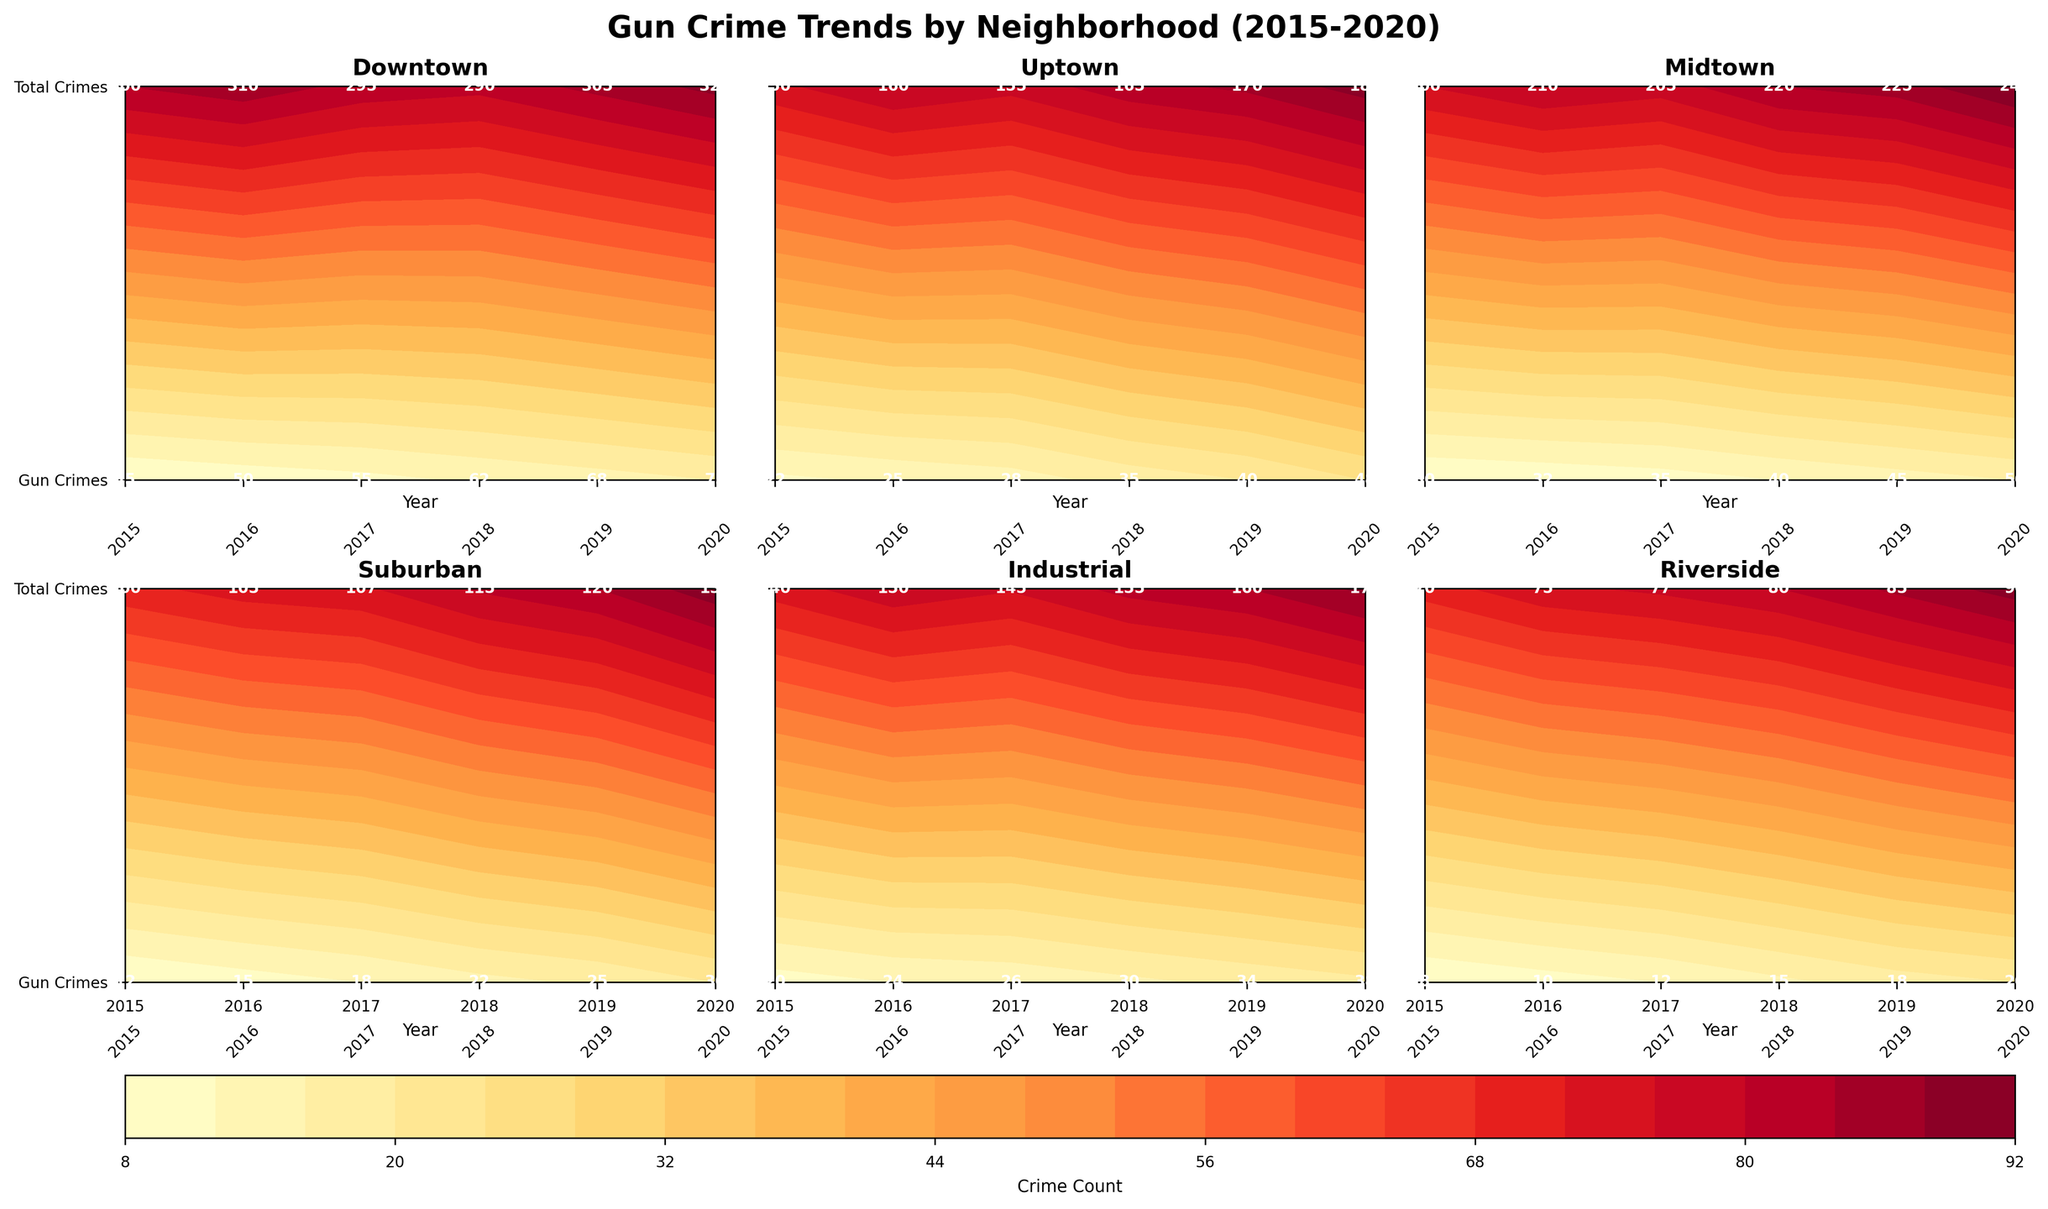What is the title of the figure? The title is typically displayed at the top of the figure; it's used to summarize the content or focus of the figure. For our plot, it reads "Gun Crime Trends by Neighborhood (2015-2020)".
Answer: Gun Crime Trends by Neighborhood (2015-2020) What does the y-axis represent in each subplot? Each subplot has a y-axis with labels that differentiate between "Gun Crimes" (at the bottom) and "Total Crimes" (at the top of the axis).
Answer: Gun Crimes and Total Crimes Which neighborhood had the highest number of gun crimes in 2020? Looking at the subplots and the labels on the contours, we can see that Downtown had the highest number of gun crimes in 2020, with a count of 75.
Answer: Downtown How did gun crimes in Uptown change from 2015 to 2020? By examining the values of gun crimes for the years 2015 through 2020 in Uptown's subplot, we observe an increasing trend: 22 in 2015, 25 in 2016, 28 in 2017, 35 in 2018, 40 in 2019, and 48 in 2020.
Answer: Increased Between Downtown and Suburban, which neighborhood showed a higher increase in gun crimes from 2015 to 2020? For Downtown, the gun crimes increased from 45 in 2015 to 75 in 2020, an increase of 30. For Suburban, they increased from 12 in 2015 to 30 in 2020, an increase of 18. Downtown had a higher increase in gun crimes.
Answer: Downtown How does the increase in total crimes from 2015 to 2020 in Midtown compare to that in Industrial? Midtown's total crimes increased from 200 in 2015 to 240 in 2020, a difference of 40. Industrial's total crimes increased from 140 in 2015 to 170 in 2020, a difference of 30. Midtown had a higher increase in total crimes.
Answer: Midtown What pattern can be observed in the contour levels for Riverside from 2015 to 2020? In Riverside's subplot, both the gun crimes and total crimes show an ascending pattern when moving from 2015 to 2020. Gun crimes increase from 8 to 20, and total crimes increase from 70 to 90.
Answer: Ascending pattern Which neighborhood had the smallest increase in gun crimes over the period 2015-2020? By comparing the data for all neighborhoods, Riverside had the smallest increase in gun crimes, moving from 8 in 2015 to 20 in 2020, an increase of 12.
Answer: Riverside How do total crimes in Industrial compare to gun crimes in the same neighborhood across the years? In the Industrial subplot, total crimes are consistently higher than gun crimes from 2015 to 2020. For example, in 2020, total crimes are 170 while gun crimes are 38.
Answer: Total crimes are higher 